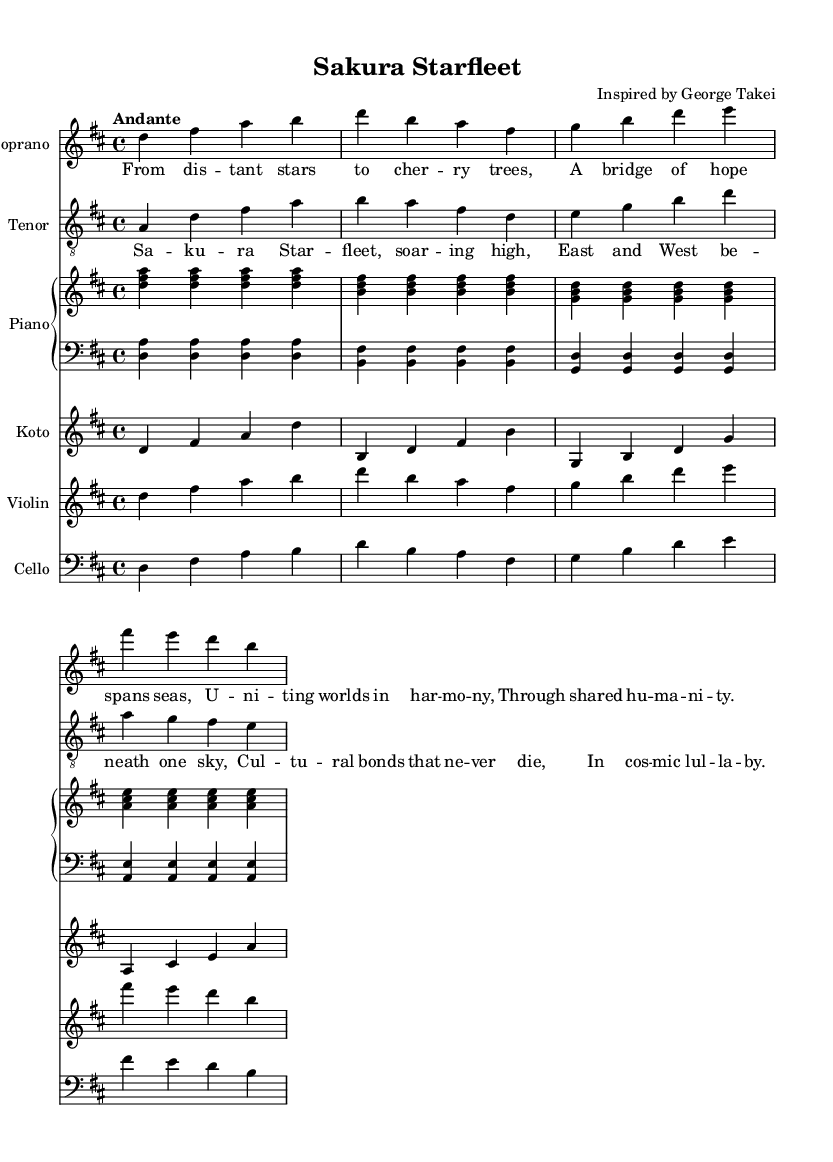What is the key signature of this music? The key signature is indicated by the sharp symbols on the staff. In this case, there are two sharps (F# and C#), which signifies it is in D major.
Answer: D major What is the time signature of the piece? The time signature is found at the beginning of the piece; it shows that there are four beats per measure. This is indicated as 4/4 in the code.
Answer: 4/4 What is the tempo marking of the music? The tempo marking is located right after the time signature. "Andante" indicates the speed, suggesting a moderate walking pace for the performers.
Answer: Andante How many different instrumental parts are included in the score? By examining the score, we can see there are six different instrumental parts: Soprano, Tenor, Piano (two staves), Koto, Violin, and Cello. Counting each part gives us the total.
Answer: Six In what form are the lyrics structured in the verse? A closer look at the verse lyrics shows that they are divided into two sections with lines alternating between pairs, indicating a rhyming structure.
Answer: Quatrain Which cultural element is specifically mentioned in the chorus? The chorus explicitly references "Sakura," which is a well-known cultural element from Japan, symbolizing cherry blossoms and related to Japanese heritage.
Answer: Sakura 